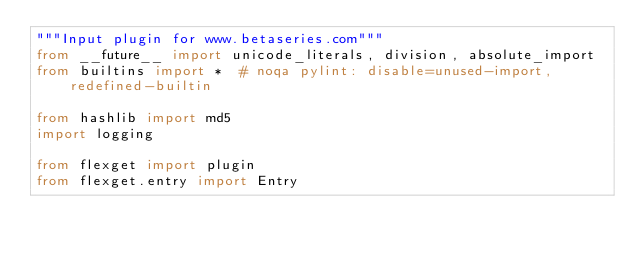<code> <loc_0><loc_0><loc_500><loc_500><_Python_>"""Input plugin for www.betaseries.com"""
from __future__ import unicode_literals, division, absolute_import
from builtins import *  # noqa pylint: disable=unused-import, redefined-builtin

from hashlib import md5
import logging

from flexget import plugin
from flexget.entry import Entry</code> 